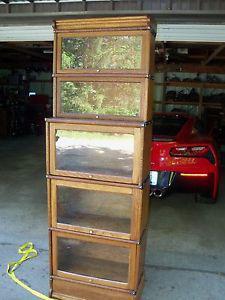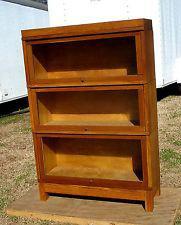The first image is the image on the left, the second image is the image on the right. For the images displayed, is the sentence "there is a book case, outdoors with 3 shelves" factually correct? Answer yes or no. Yes. The first image is the image on the left, the second image is the image on the right. For the images displayed, is the sentence "One of the photos shows a wooden bookcase with at most three shelves." factually correct? Answer yes or no. Yes. 